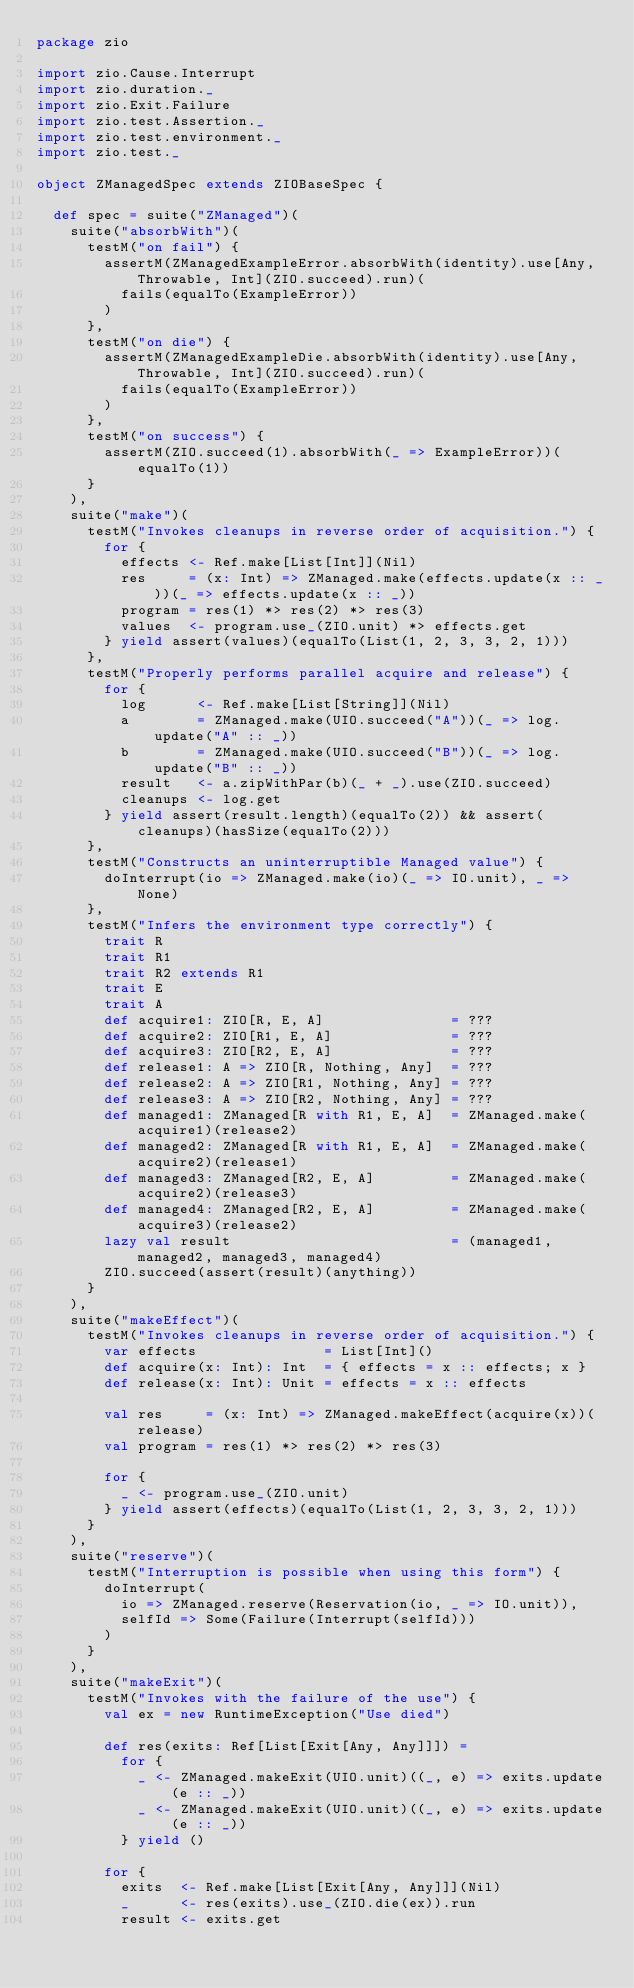<code> <loc_0><loc_0><loc_500><loc_500><_Scala_>package zio

import zio.Cause.Interrupt
import zio.duration._
import zio.Exit.Failure
import zio.test.Assertion._
import zio.test.environment._
import zio.test._

object ZManagedSpec extends ZIOBaseSpec {

  def spec = suite("ZManaged")(
    suite("absorbWith")(
      testM("on fail") {
        assertM(ZManagedExampleError.absorbWith(identity).use[Any, Throwable, Int](ZIO.succeed).run)(
          fails(equalTo(ExampleError))
        )
      },
      testM("on die") {
        assertM(ZManagedExampleDie.absorbWith(identity).use[Any, Throwable, Int](ZIO.succeed).run)(
          fails(equalTo(ExampleError))
        )
      },
      testM("on success") {
        assertM(ZIO.succeed(1).absorbWith(_ => ExampleError))(equalTo(1))
      }
    ),
    suite("make")(
      testM("Invokes cleanups in reverse order of acquisition.") {
        for {
          effects <- Ref.make[List[Int]](Nil)
          res     = (x: Int) => ZManaged.make(effects.update(x :: _))(_ => effects.update(x :: _))
          program = res(1) *> res(2) *> res(3)
          values  <- program.use_(ZIO.unit) *> effects.get
        } yield assert(values)(equalTo(List(1, 2, 3, 3, 2, 1)))
      },
      testM("Properly performs parallel acquire and release") {
        for {
          log      <- Ref.make[List[String]](Nil)
          a        = ZManaged.make(UIO.succeed("A"))(_ => log.update("A" :: _))
          b        = ZManaged.make(UIO.succeed("B"))(_ => log.update("B" :: _))
          result   <- a.zipWithPar(b)(_ + _).use(ZIO.succeed)
          cleanups <- log.get
        } yield assert(result.length)(equalTo(2)) && assert(cleanups)(hasSize(equalTo(2)))
      },
      testM("Constructs an uninterruptible Managed value") {
        doInterrupt(io => ZManaged.make(io)(_ => IO.unit), _ => None)
      },
      testM("Infers the environment type correctly") {
        trait R
        trait R1
        trait R2 extends R1
        trait E
        trait A
        def acquire1: ZIO[R, E, A]               = ???
        def acquire2: ZIO[R1, E, A]              = ???
        def acquire3: ZIO[R2, E, A]              = ???
        def release1: A => ZIO[R, Nothing, Any]  = ???
        def release2: A => ZIO[R1, Nothing, Any] = ???
        def release3: A => ZIO[R2, Nothing, Any] = ???
        def managed1: ZManaged[R with R1, E, A]  = ZManaged.make(acquire1)(release2)
        def managed2: ZManaged[R with R1, E, A]  = ZManaged.make(acquire2)(release1)
        def managed3: ZManaged[R2, E, A]         = ZManaged.make(acquire2)(release3)
        def managed4: ZManaged[R2, E, A]         = ZManaged.make(acquire3)(release2)
        lazy val result                          = (managed1, managed2, managed3, managed4)
        ZIO.succeed(assert(result)(anything))
      }
    ),
    suite("makeEffect")(
      testM("Invokes cleanups in reverse order of acquisition.") {
        var effects               = List[Int]()
        def acquire(x: Int): Int  = { effects = x :: effects; x }
        def release(x: Int): Unit = effects = x :: effects

        val res     = (x: Int) => ZManaged.makeEffect(acquire(x))(release)
        val program = res(1) *> res(2) *> res(3)

        for {
          _ <- program.use_(ZIO.unit)
        } yield assert(effects)(equalTo(List(1, 2, 3, 3, 2, 1)))
      }
    ),
    suite("reserve")(
      testM("Interruption is possible when using this form") {
        doInterrupt(
          io => ZManaged.reserve(Reservation(io, _ => IO.unit)),
          selfId => Some(Failure(Interrupt(selfId)))
        )
      }
    ),
    suite("makeExit")(
      testM("Invokes with the failure of the use") {
        val ex = new RuntimeException("Use died")

        def res(exits: Ref[List[Exit[Any, Any]]]) =
          for {
            _ <- ZManaged.makeExit(UIO.unit)((_, e) => exits.update(e :: _))
            _ <- ZManaged.makeExit(UIO.unit)((_, e) => exits.update(e :: _))
          } yield ()

        for {
          exits  <- Ref.make[List[Exit[Any, Any]]](Nil)
          _      <- res(exits).use_(ZIO.die(ex)).run
          result <- exits.get</code> 